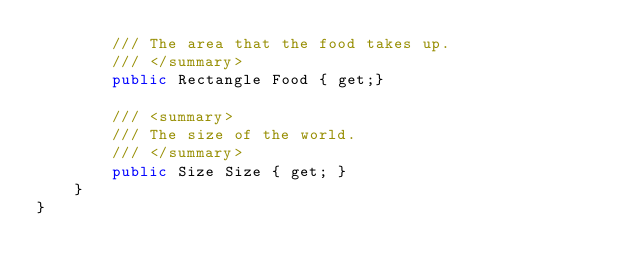Convert code to text. <code><loc_0><loc_0><loc_500><loc_500><_C#_>        /// The area that the food takes up.
        /// </summary>
        public Rectangle Food { get;}

        /// <summary>
        /// The size of the world.
        /// </summary>
        public Size Size { get; }
    }
}</code> 